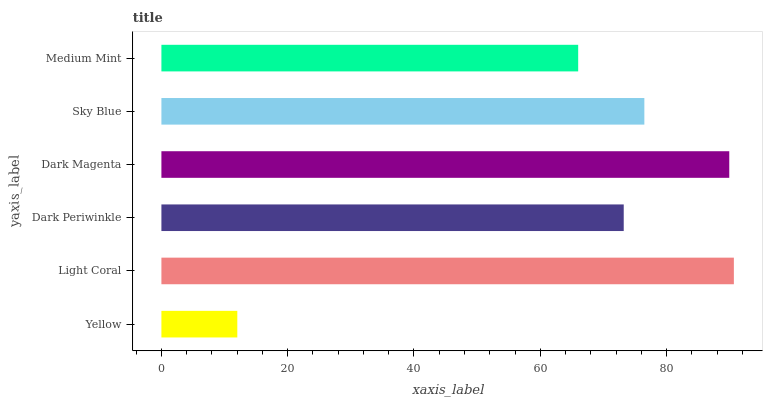Is Yellow the minimum?
Answer yes or no. Yes. Is Light Coral the maximum?
Answer yes or no. Yes. Is Dark Periwinkle the minimum?
Answer yes or no. No. Is Dark Periwinkle the maximum?
Answer yes or no. No. Is Light Coral greater than Dark Periwinkle?
Answer yes or no. Yes. Is Dark Periwinkle less than Light Coral?
Answer yes or no. Yes. Is Dark Periwinkle greater than Light Coral?
Answer yes or no. No. Is Light Coral less than Dark Periwinkle?
Answer yes or no. No. Is Sky Blue the high median?
Answer yes or no. Yes. Is Dark Periwinkle the low median?
Answer yes or no. Yes. Is Medium Mint the high median?
Answer yes or no. No. Is Medium Mint the low median?
Answer yes or no. No. 